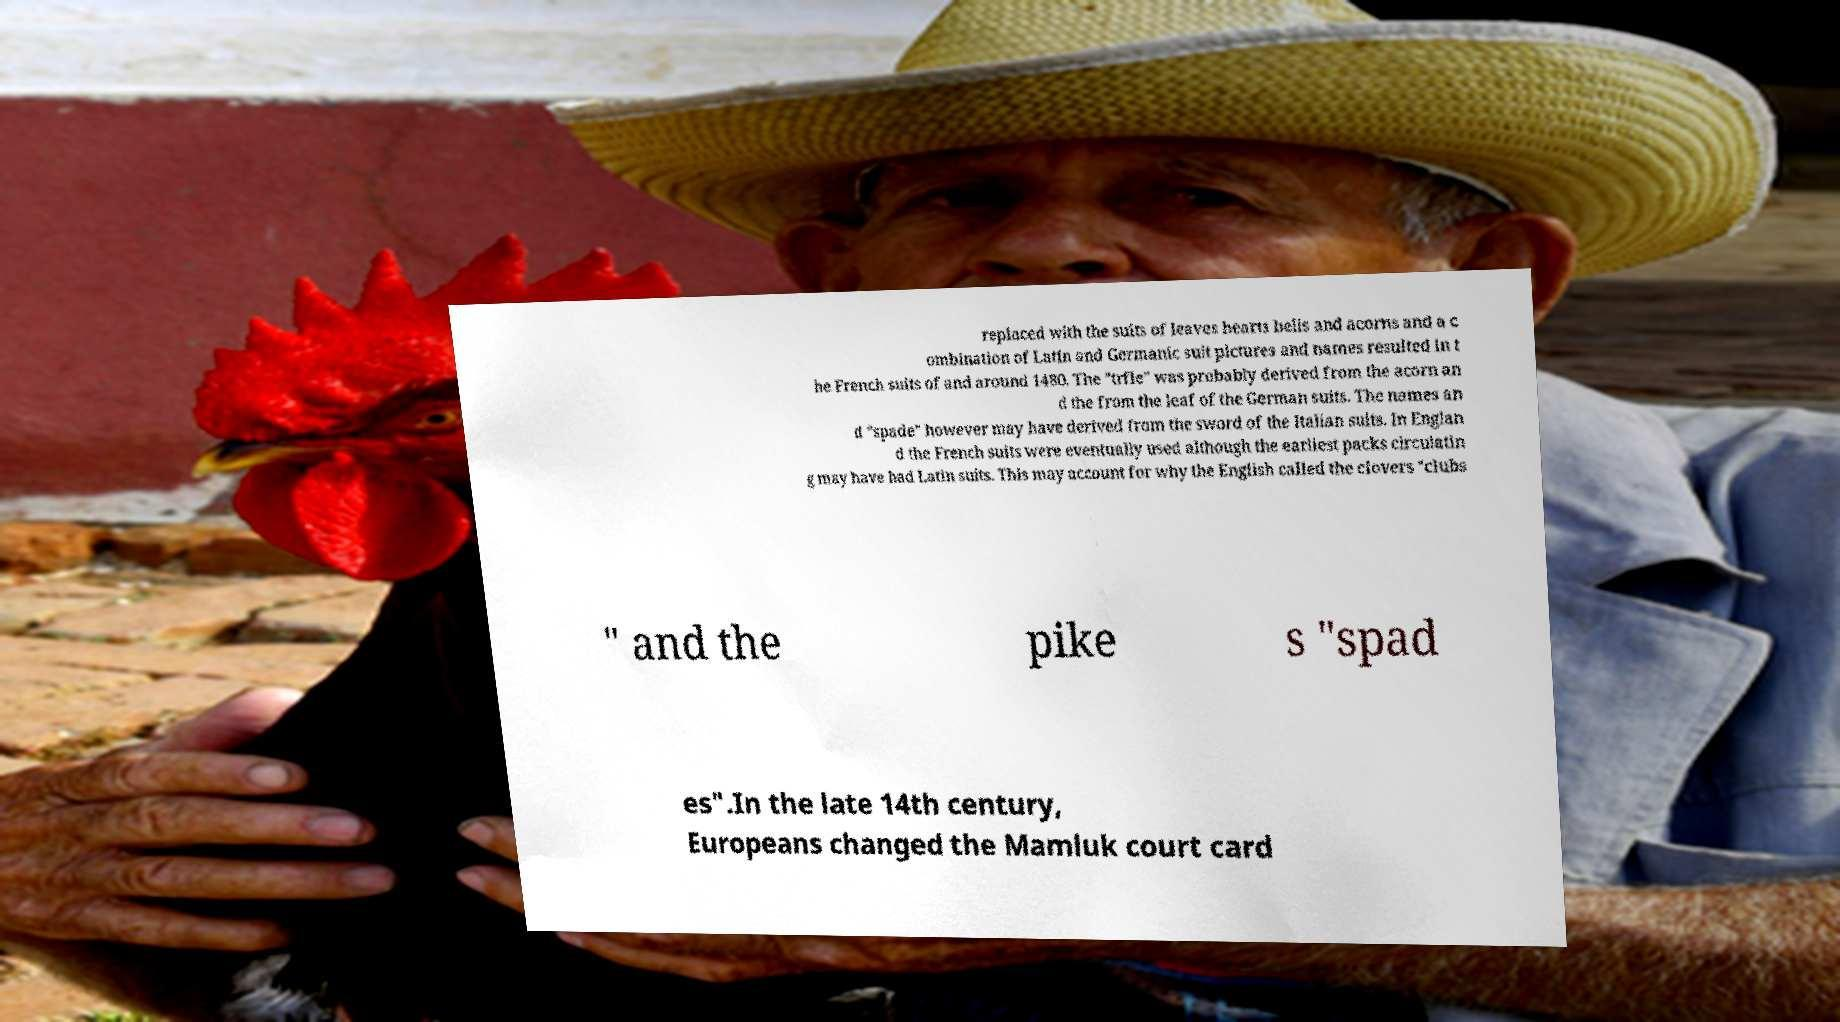I need the written content from this picture converted into text. Can you do that? replaced with the suits of leaves hearts bells and acorns and a c ombination of Latin and Germanic suit pictures and names resulted in t he French suits of and around 1480. The "trfle" was probably derived from the acorn an d the from the leaf of the German suits. The names an d "spade" however may have derived from the sword of the Italian suits. In Englan d the French suits were eventually used although the earliest packs circulatin g may have had Latin suits. This may account for why the English called the clovers "clubs " and the pike s "spad es".In the late 14th century, Europeans changed the Mamluk court card 